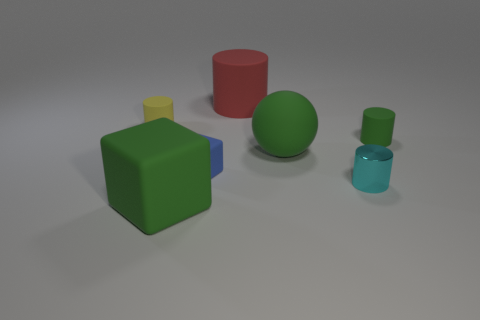Is there any other thing that is made of the same material as the tiny cyan object?
Make the answer very short. No. Are there any objects that are right of the big matte object behind the green cylinder?
Make the answer very short. Yes. There is a yellow thing that is the same material as the tiny blue cube; what is its shape?
Your response must be concise. Cylinder. Is there any other thing that has the same color as the tiny cube?
Offer a terse response. No. There is a large thing behind the tiny matte cylinder on the left side of the tiny cyan cylinder; what is its material?
Provide a short and direct response. Rubber. Is there a large red object of the same shape as the blue object?
Keep it short and to the point. No. How many other things are there of the same shape as the small green rubber thing?
Your answer should be compact. 3. There is a large rubber object that is both to the left of the sphere and to the right of the green block; what shape is it?
Your answer should be very brief. Cylinder. What is the size of the green matte object to the left of the red object?
Make the answer very short. Large. Do the cyan object and the blue object have the same size?
Offer a very short reply. Yes. 